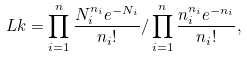Convert formula to latex. <formula><loc_0><loc_0><loc_500><loc_500>L k = \prod _ { i = 1 } ^ { n } \frac { N _ { i } ^ { n _ { i } } e ^ { - N _ { i } } } { n _ { i } ! } / \prod _ { i = 1 } ^ { n } \frac { n _ { i } ^ { n _ { i } } e ^ { - n _ { i } } } { n _ { i } ! } ,</formula> 